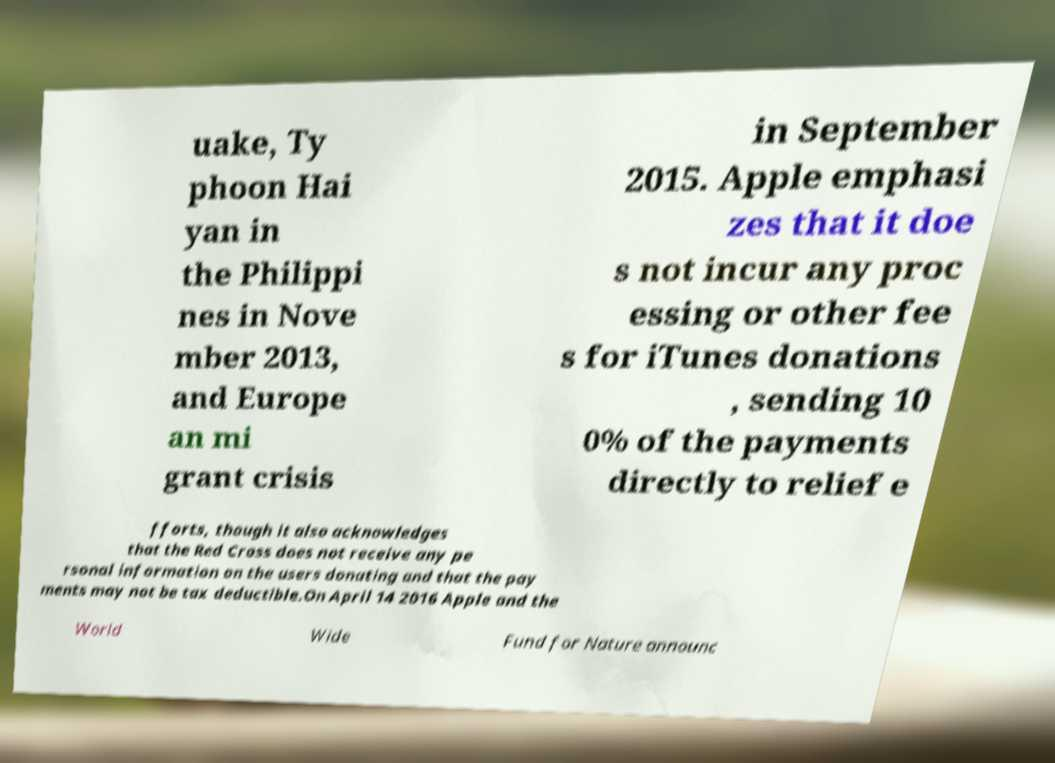For documentation purposes, I need the text within this image transcribed. Could you provide that? uake, Ty phoon Hai yan in the Philippi nes in Nove mber 2013, and Europe an mi grant crisis in September 2015. Apple emphasi zes that it doe s not incur any proc essing or other fee s for iTunes donations , sending 10 0% of the payments directly to relief e fforts, though it also acknowledges that the Red Cross does not receive any pe rsonal information on the users donating and that the pay ments may not be tax deductible.On April 14 2016 Apple and the World Wide Fund for Nature announc 